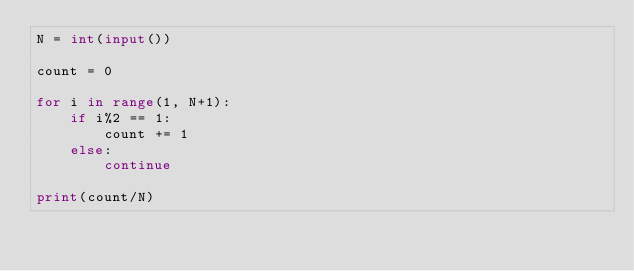<code> <loc_0><loc_0><loc_500><loc_500><_Python_>N = int(input())

count = 0

for i in range(1, N+1):
    if i%2 == 1:
        count += 1
    else:
        continue

print(count/N)
</code> 